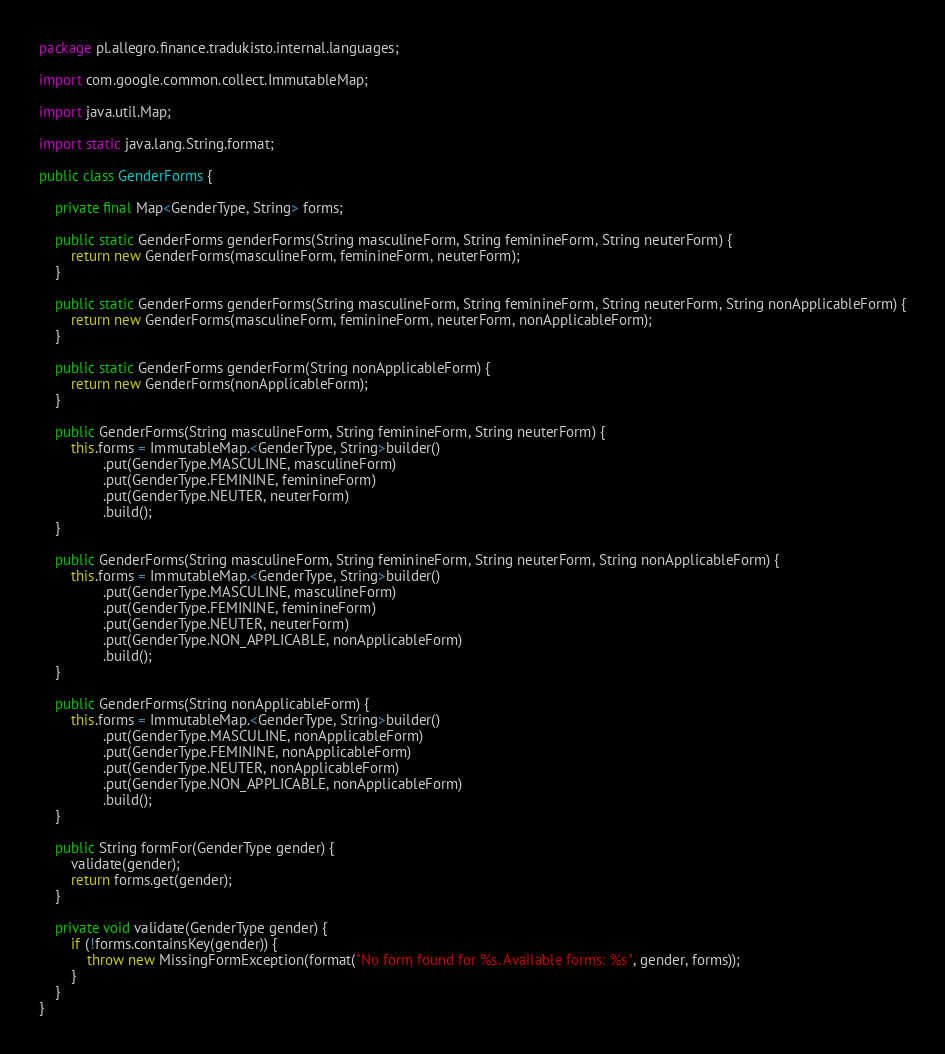<code> <loc_0><loc_0><loc_500><loc_500><_Java_>package pl.allegro.finance.tradukisto.internal.languages;

import com.google.common.collect.ImmutableMap;

import java.util.Map;

import static java.lang.String.format;

public class GenderForms {

    private final Map<GenderType, String> forms;

    public static GenderForms genderForms(String masculineForm, String feminineForm, String neuterForm) {
        return new GenderForms(masculineForm, feminineForm, neuterForm);
    }

    public static GenderForms genderForms(String masculineForm, String feminineForm, String neuterForm, String nonApplicableForm) {
        return new GenderForms(masculineForm, feminineForm, neuterForm, nonApplicableForm);
    }

    public static GenderForms genderForm(String nonApplicableForm) {
        return new GenderForms(nonApplicableForm);
    }

    public GenderForms(String masculineForm, String feminineForm, String neuterForm) {
        this.forms = ImmutableMap.<GenderType, String>builder()
                .put(GenderType.MASCULINE, masculineForm)
                .put(GenderType.FEMININE, feminineForm)
                .put(GenderType.NEUTER, neuterForm)
                .build();
    }

    public GenderForms(String masculineForm, String feminineForm, String neuterForm, String nonApplicableForm) {
        this.forms = ImmutableMap.<GenderType, String>builder()
                .put(GenderType.MASCULINE, masculineForm)
                .put(GenderType.FEMININE, feminineForm)
                .put(GenderType.NEUTER, neuterForm)
                .put(GenderType.NON_APPLICABLE, nonApplicableForm)
                .build();
    }

    public GenderForms(String nonApplicableForm) {
        this.forms = ImmutableMap.<GenderType, String>builder()
                .put(GenderType.MASCULINE, nonApplicableForm)
                .put(GenderType.FEMININE, nonApplicableForm)
                .put(GenderType.NEUTER, nonApplicableForm)
                .put(GenderType.NON_APPLICABLE, nonApplicableForm)
                .build();
    }

    public String formFor(GenderType gender) {
        validate(gender);
        return forms.get(gender);
    }

    private void validate(GenderType gender) {
        if (!forms.containsKey(gender)) {
            throw new MissingFormException(format("No form found for %s. Available forms: %s", gender, forms));
        }
    }
}
</code> 